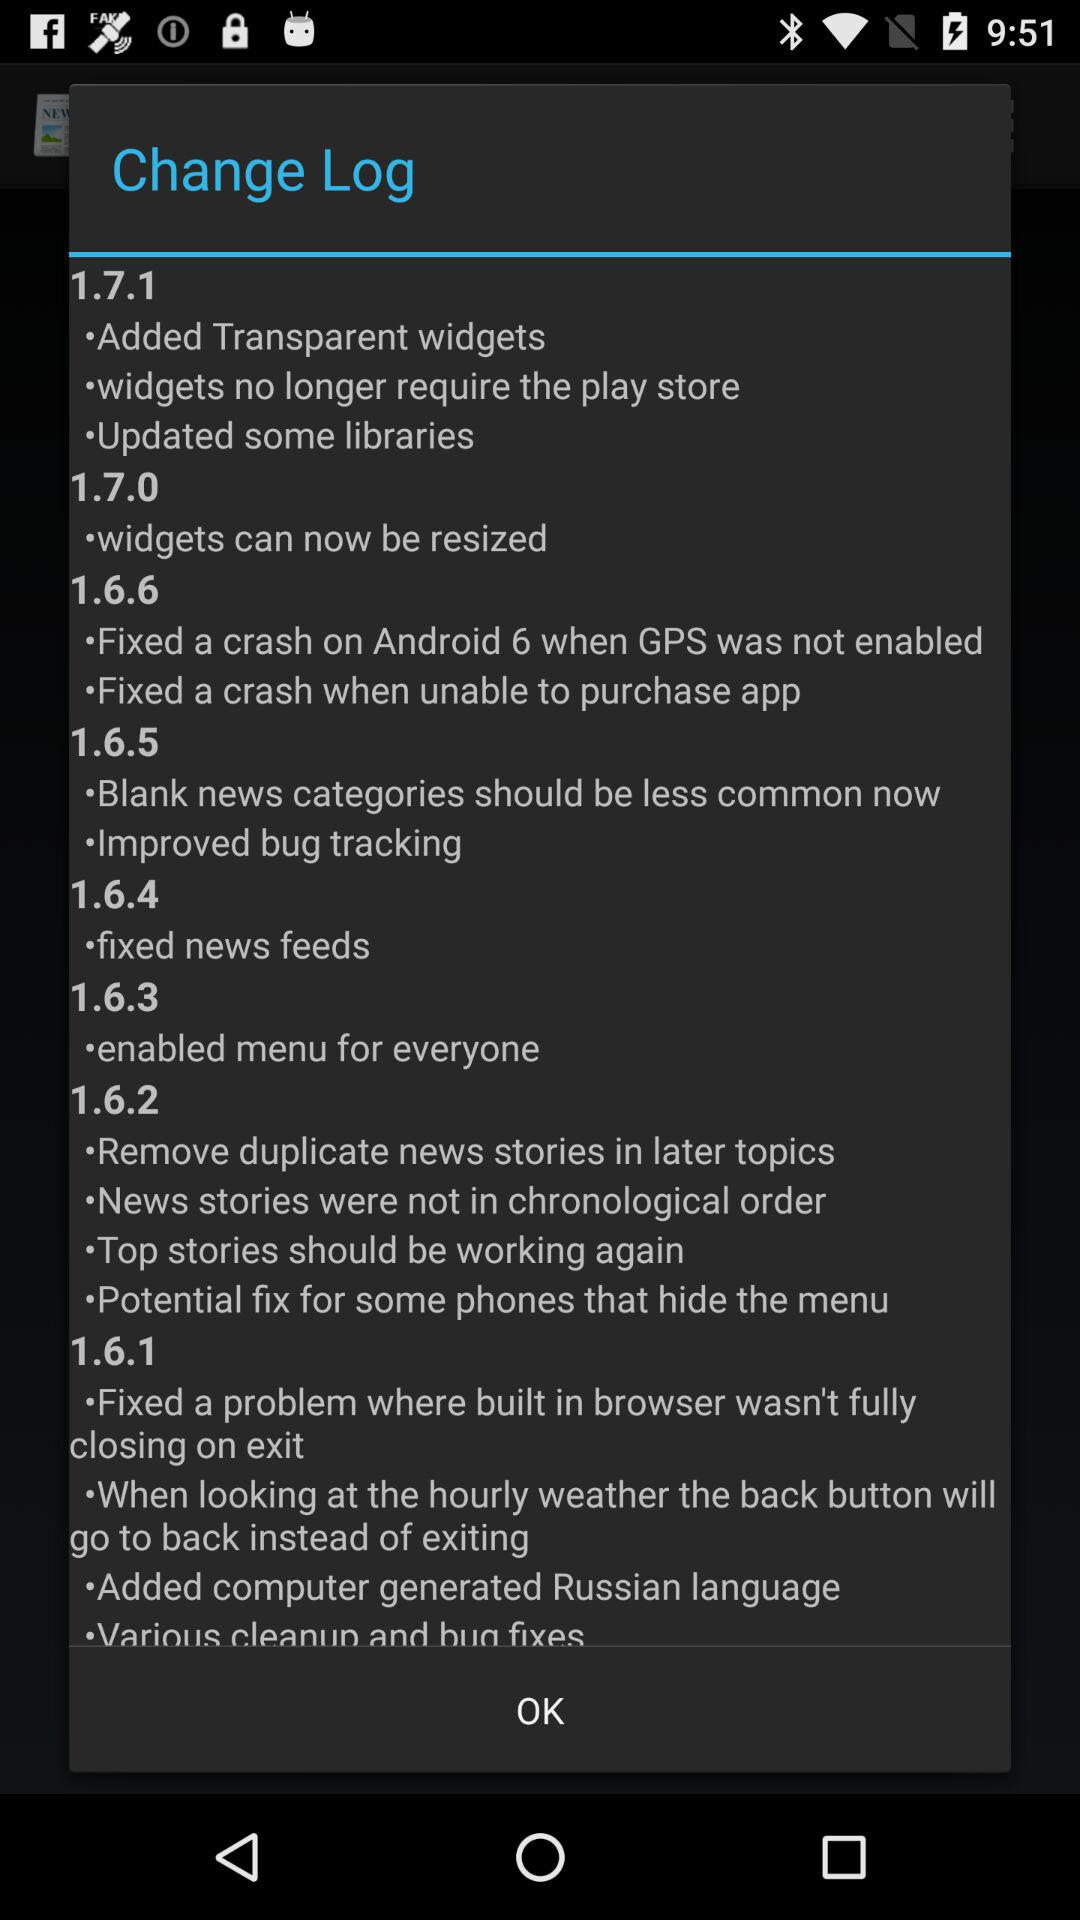What is the change log in version 1.6.2? The change log is "Remove duplicate news stories in later topics", "News stories were not in chronological order", "Top stories should be working again" and "Potential fix for some phones that hide the menu". 